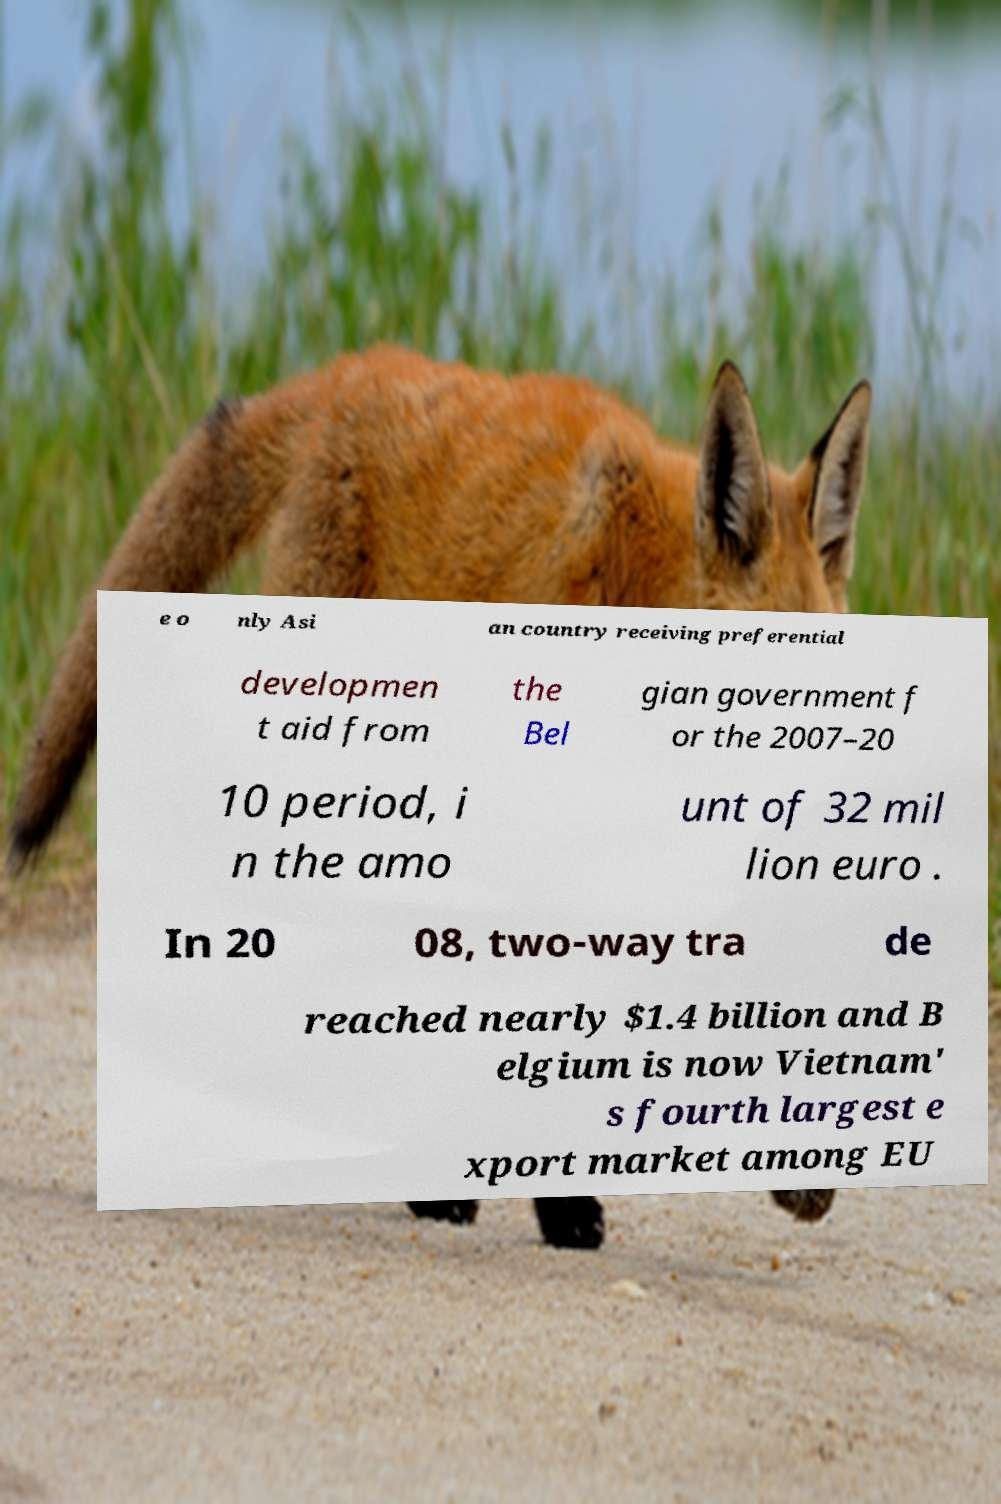Can you accurately transcribe the text from the provided image for me? e o nly Asi an country receiving preferential developmen t aid from the Bel gian government f or the 2007–20 10 period, i n the amo unt of 32 mil lion euro . In 20 08, two-way tra de reached nearly $1.4 billion and B elgium is now Vietnam' s fourth largest e xport market among EU 